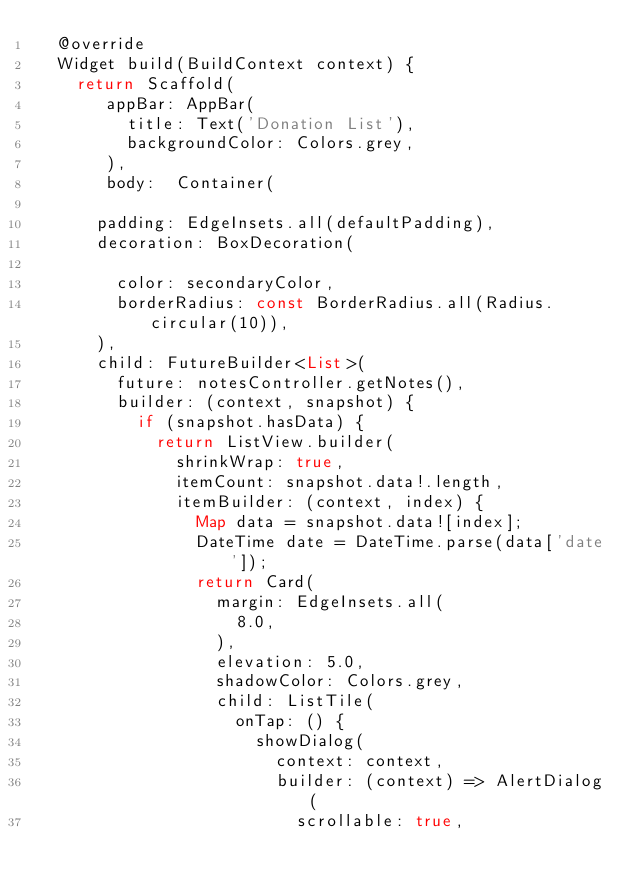Convert code to text. <code><loc_0><loc_0><loc_500><loc_500><_Dart_>  @override
  Widget build(BuildContext context) {
    return Scaffold(
       appBar: AppBar(
         title: Text('Donation List'),
         backgroundColor: Colors.grey,
       ),
       body:  Container(
         
      padding: EdgeInsets.all(defaultPadding),
      decoration: BoxDecoration(
        
        color: secondaryColor,
        borderRadius: const BorderRadius.all(Radius.circular(10)),
      ),
      child: FutureBuilder<List>(
        future: notesController.getNotes(),
        builder: (context, snapshot) {
          if (snapshot.hasData) {
            return ListView.builder(
              shrinkWrap: true,
              itemCount: snapshot.data!.length,
              itemBuilder: (context, index) {
                Map data = snapshot.data![index];
                DateTime date = DateTime.parse(data['date']);
                return Card(
                  margin: EdgeInsets.all(
                    8.0,
                  ),
                  elevation: 5.0,
                  shadowColor: Colors.grey,
                  child: ListTile(
                    onTap: () {
                      showDialog(
                        context: context,
                        builder: (context) => AlertDialog(
                          scrollable: true,</code> 